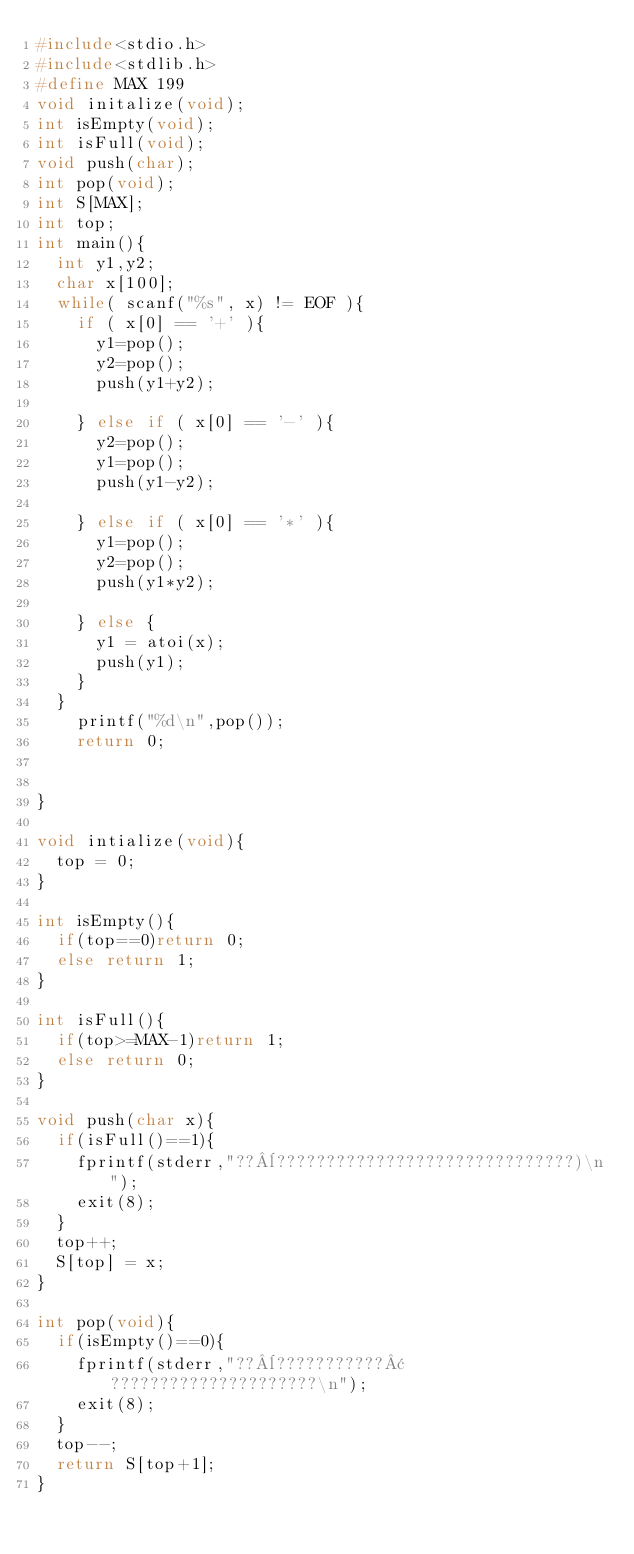<code> <loc_0><loc_0><loc_500><loc_500><_C_>#include<stdio.h>
#include<stdlib.h>
#define MAX 199
void initalize(void);
int isEmpty(void);
int isFull(void);
void push(char);
int pop(void);
int S[MAX];
int top;
int main(){
  int y1,y2;
  char x[100];
  while( scanf("%s", x) != EOF ){
    if ( x[0] == '+' ){
      y1=pop();
      y2=pop();
      push(y1+y2);
      
    } else if ( x[0] == '-' ){
      y2=pop();
      y1=pop();
      push(y1-y2);
      
    } else if ( x[0] == '*' ){
      y1=pop();
      y2=pop();
      push(y1*y2);
      
    } else {
      y1 = atoi(x);
      push(y1);
    }
  }
    printf("%d\n",pop());
    return 0;
    
  
}

void intialize(void){
  top = 0;
}

int isEmpty(){
  if(top==0)return 0;
  else return 1;
}

int isFull(){
  if(top>=MAX-1)return 1;
  else return 0;
}

void push(char x){
  if(isFull()==1){
    fprintf(stderr,"??¨??????????????????????????????)\n");
    exit(8);
  }
  top++;
  S[top] = x;
}

int pop(void){   
  if(isEmpty()==0){
    fprintf(stderr,"??¨???????????¢?????????????????????\n");
    exit(8);
  }
  top--;
  return S[top+1];
}</code> 